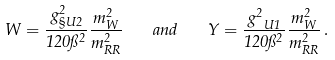<formula> <loc_0><loc_0><loc_500><loc_500>W = \frac { g _ { \S U { 2 } } ^ { 2 } } { 1 2 0 \pi ^ { 2 } } \frac { m _ { W } ^ { 2 } } { m _ { R R } ^ { 2 } } \quad a n d \quad Y = \frac { g _ { \ U { 1 } } ^ { 2 } } { 1 2 0 \pi ^ { 2 } } \frac { m _ { W } ^ { 2 } } { m _ { R R } ^ { 2 } } \, .</formula> 